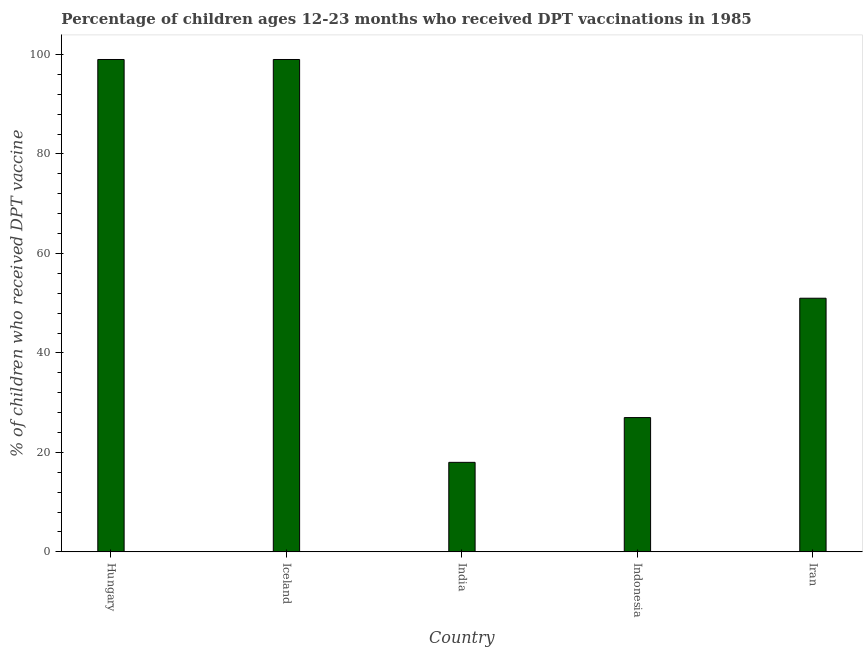Does the graph contain grids?
Give a very brief answer. No. What is the title of the graph?
Provide a succinct answer. Percentage of children ages 12-23 months who received DPT vaccinations in 1985. What is the label or title of the Y-axis?
Your answer should be compact. % of children who received DPT vaccine. Across all countries, what is the maximum percentage of children who received dpt vaccine?
Make the answer very short. 99. Across all countries, what is the minimum percentage of children who received dpt vaccine?
Offer a terse response. 18. In which country was the percentage of children who received dpt vaccine maximum?
Offer a terse response. Hungary. In which country was the percentage of children who received dpt vaccine minimum?
Provide a short and direct response. India. What is the sum of the percentage of children who received dpt vaccine?
Provide a succinct answer. 294. What is the average percentage of children who received dpt vaccine per country?
Give a very brief answer. 58.8. In how many countries, is the percentage of children who received dpt vaccine greater than 12 %?
Provide a succinct answer. 5. What is the ratio of the percentage of children who received dpt vaccine in Indonesia to that in Iran?
Keep it short and to the point. 0.53. Is the difference between the percentage of children who received dpt vaccine in Hungary and Iran greater than the difference between any two countries?
Your answer should be compact. No. Is the sum of the percentage of children who received dpt vaccine in Indonesia and Iran greater than the maximum percentage of children who received dpt vaccine across all countries?
Make the answer very short. No. What is the difference between the highest and the lowest percentage of children who received dpt vaccine?
Your answer should be compact. 81. How many bars are there?
Provide a succinct answer. 5. Are all the bars in the graph horizontal?
Offer a terse response. No. What is the % of children who received DPT vaccine in Iceland?
Offer a very short reply. 99. What is the % of children who received DPT vaccine of Indonesia?
Offer a terse response. 27. What is the difference between the % of children who received DPT vaccine in Hungary and Indonesia?
Ensure brevity in your answer.  72. What is the difference between the % of children who received DPT vaccine in India and Indonesia?
Keep it short and to the point. -9. What is the difference between the % of children who received DPT vaccine in India and Iran?
Your response must be concise. -33. What is the ratio of the % of children who received DPT vaccine in Hungary to that in Iceland?
Your response must be concise. 1. What is the ratio of the % of children who received DPT vaccine in Hungary to that in Indonesia?
Your answer should be compact. 3.67. What is the ratio of the % of children who received DPT vaccine in Hungary to that in Iran?
Ensure brevity in your answer.  1.94. What is the ratio of the % of children who received DPT vaccine in Iceland to that in India?
Provide a succinct answer. 5.5. What is the ratio of the % of children who received DPT vaccine in Iceland to that in Indonesia?
Offer a very short reply. 3.67. What is the ratio of the % of children who received DPT vaccine in Iceland to that in Iran?
Provide a short and direct response. 1.94. What is the ratio of the % of children who received DPT vaccine in India to that in Indonesia?
Offer a very short reply. 0.67. What is the ratio of the % of children who received DPT vaccine in India to that in Iran?
Make the answer very short. 0.35. What is the ratio of the % of children who received DPT vaccine in Indonesia to that in Iran?
Offer a very short reply. 0.53. 